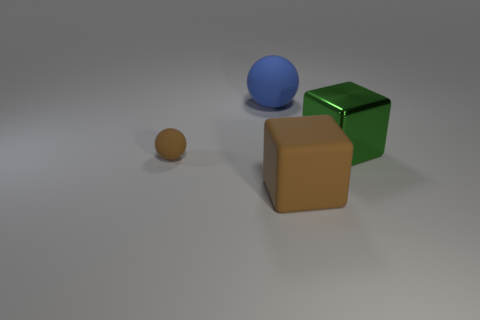Add 4 gray things. How many objects exist? 8 Subtract all blue balls. How many balls are left? 1 Subtract 2 cubes. How many cubes are left? 0 Subtract all purple blocks. Subtract all gray balls. How many blocks are left? 2 Subtract all cyan balls. How many green blocks are left? 1 Subtract all big rubber spheres. Subtract all gray rubber cylinders. How many objects are left? 3 Add 4 green objects. How many green objects are left? 5 Add 2 green metal objects. How many green metal objects exist? 3 Subtract 0 green cylinders. How many objects are left? 4 